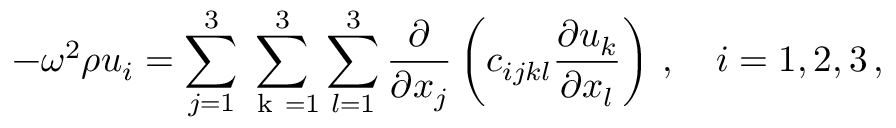<formula> <loc_0><loc_0><loc_500><loc_500>- \omega ^ { 2 } \rho u _ { i } = \sum _ { j = 1 } ^ { 3 } \sum _ { k = 1 } ^ { 3 } \sum _ { l = 1 } ^ { 3 } \frac { \partial } { \partial x _ { j } } \left ( c _ { i j k l } \frac { \partial u _ { k } } { \partial x _ { l } } \right ) \, , \quad i = 1 , 2 , 3 \, ,</formula> 